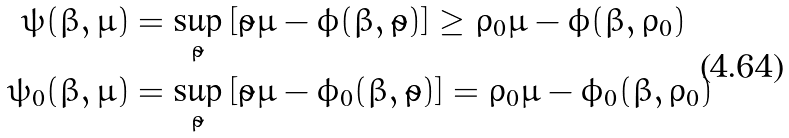<formula> <loc_0><loc_0><loc_500><loc_500>\psi ( \beta , \mu ) & = \sup _ { \tilde { \rho } } \left [ \tilde { \rho } \mu - \phi ( \beta , \tilde { \rho } ) \right ] \geq \rho _ { 0 } \mu - \phi ( \beta , \rho _ { 0 } ) \\ \psi _ { 0 } ( \beta , \mu ) & = \sup _ { \tilde { \rho } } \left [ \tilde { \rho } \mu - \phi _ { 0 } ( \beta , \tilde { \rho } ) \right ] = \rho _ { 0 } \mu - \phi _ { 0 } ( \beta , \rho _ { 0 } )</formula> 